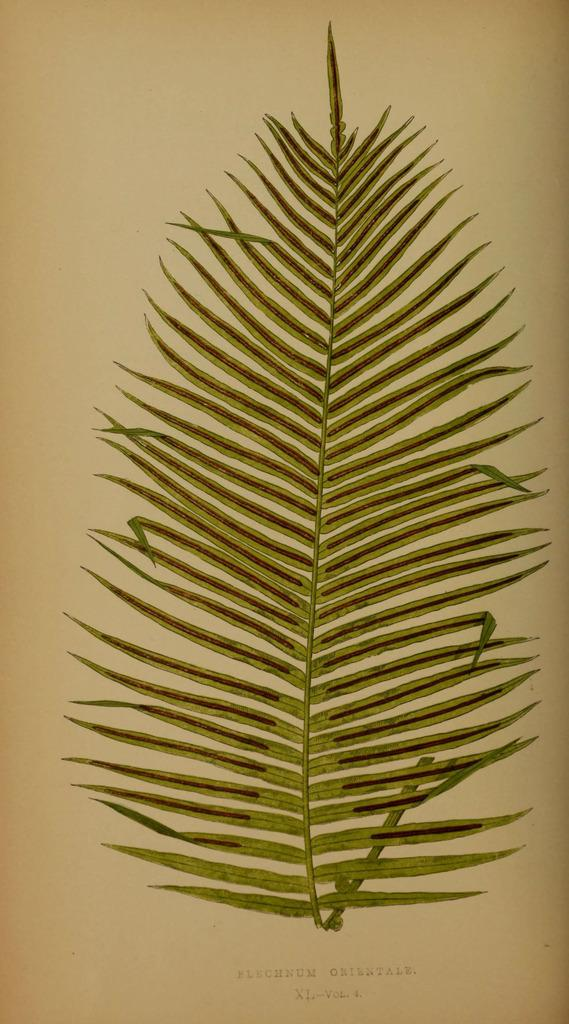What is the main subject of the paper in the image? The paper contains a painting. What is depicted in the painting? The painting depicts a leaf. What colors are used to paint the leaf? The leaf is in green and brown colors. How many dinosaurs are present in the painting on the paper? There are no dinosaurs depicted in the painting on the paper; it features a leaf. What type of base is supporting the paper in the image? The image does not show any base supporting the paper; it only shows the paper with the painting. 